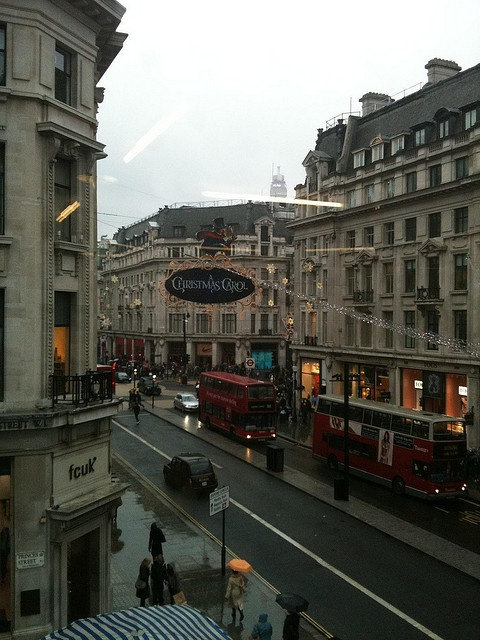Describe the objects in this image and their specific colors. I can see bus in gray and black tones, bus in gray, black, maroon, and brown tones, people in gray, black, and maroon tones, car in gray and black tones, and people in gray, black, and darkgreen tones in this image. 